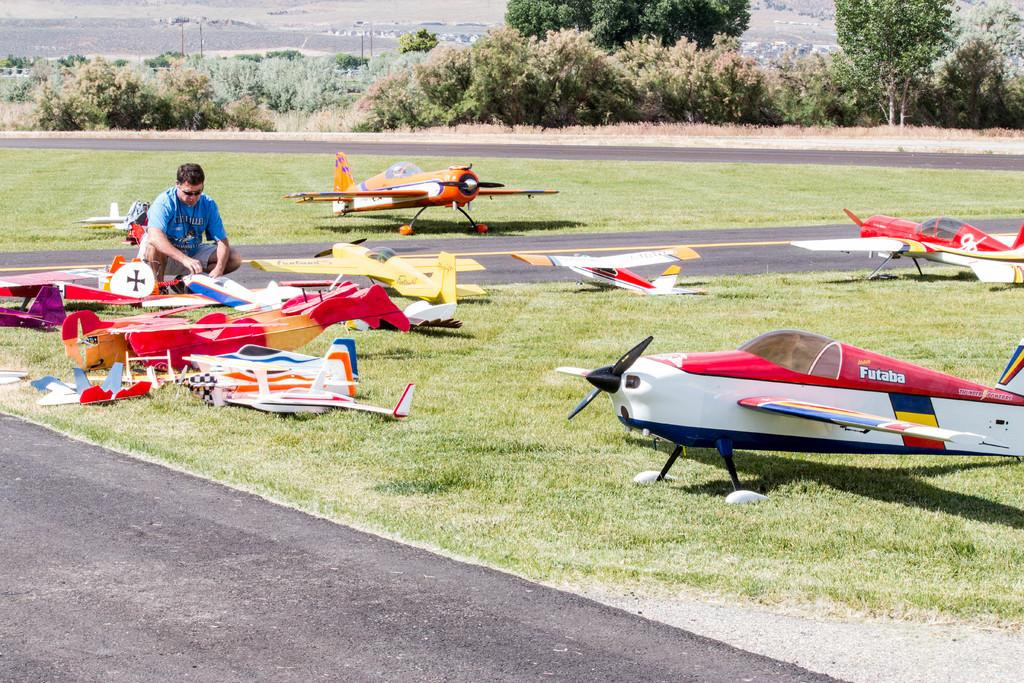<image>
Offer a succinct explanation of the picture presented. one of the model planes in the field are called Futaba 